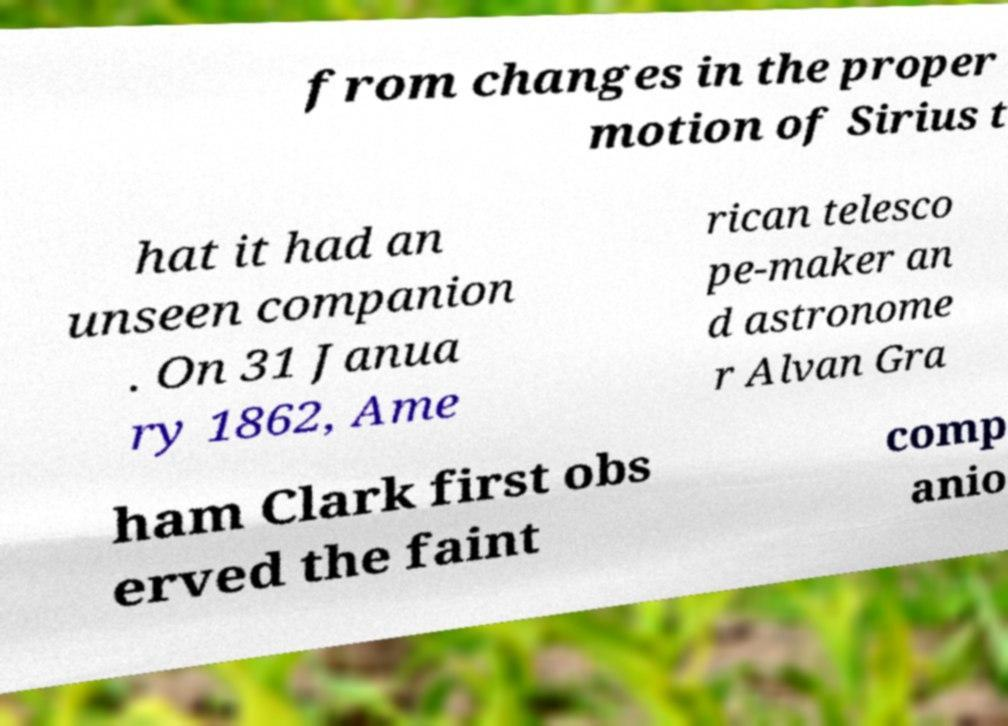For documentation purposes, I need the text within this image transcribed. Could you provide that? from changes in the proper motion of Sirius t hat it had an unseen companion . On 31 Janua ry 1862, Ame rican telesco pe-maker an d astronome r Alvan Gra ham Clark first obs erved the faint comp anio 